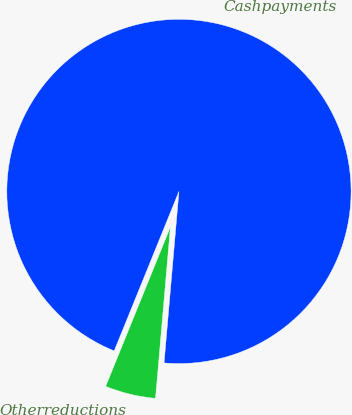<chart> <loc_0><loc_0><loc_500><loc_500><pie_chart><fcel>Cashpayments<fcel>Otherreductions<nl><fcel>95.24%<fcel>4.76%<nl></chart> 